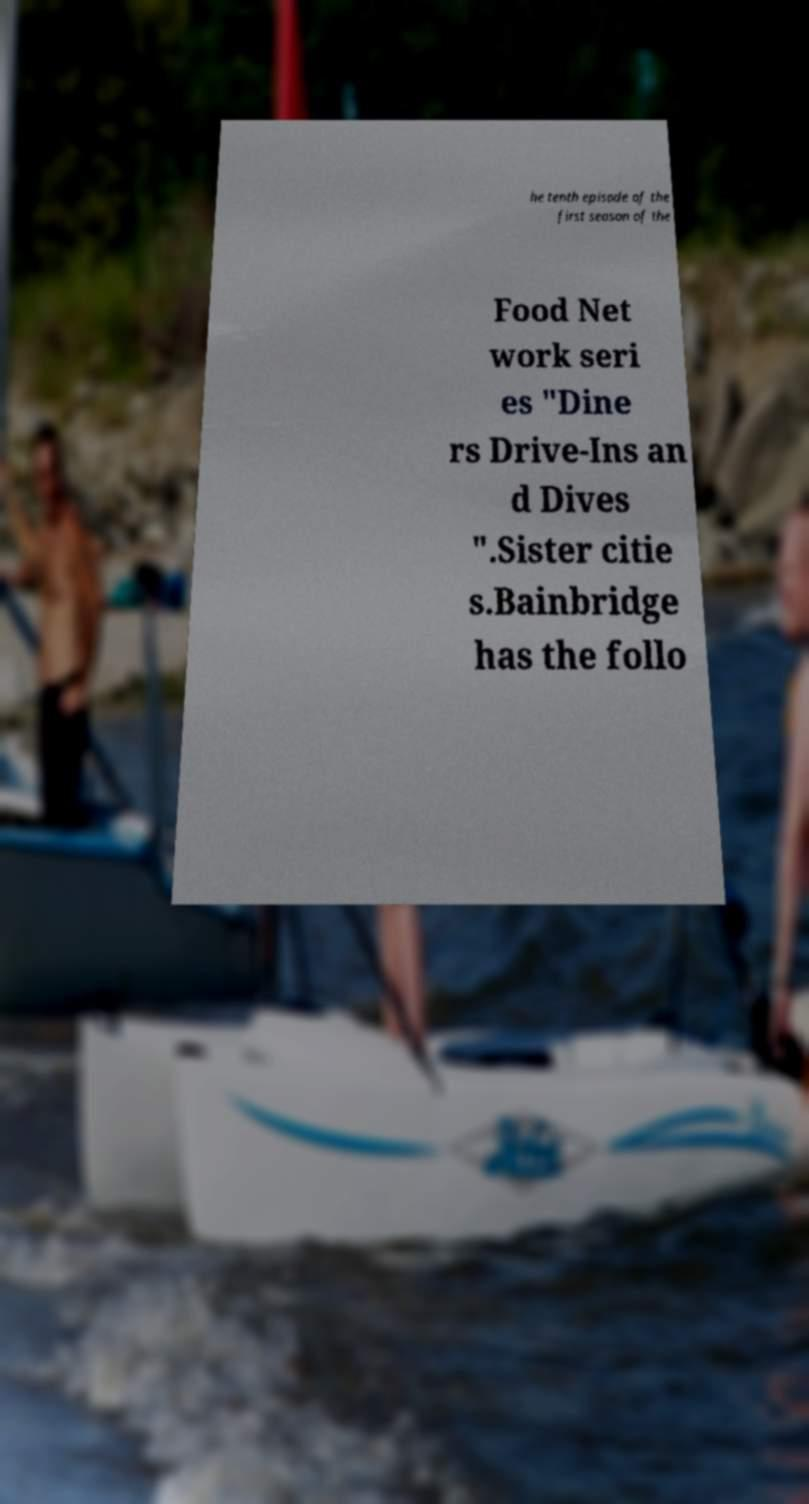Please identify and transcribe the text found in this image. he tenth episode of the first season of the Food Net work seri es "Dine rs Drive-Ins an d Dives ".Sister citie s.Bainbridge has the follo 